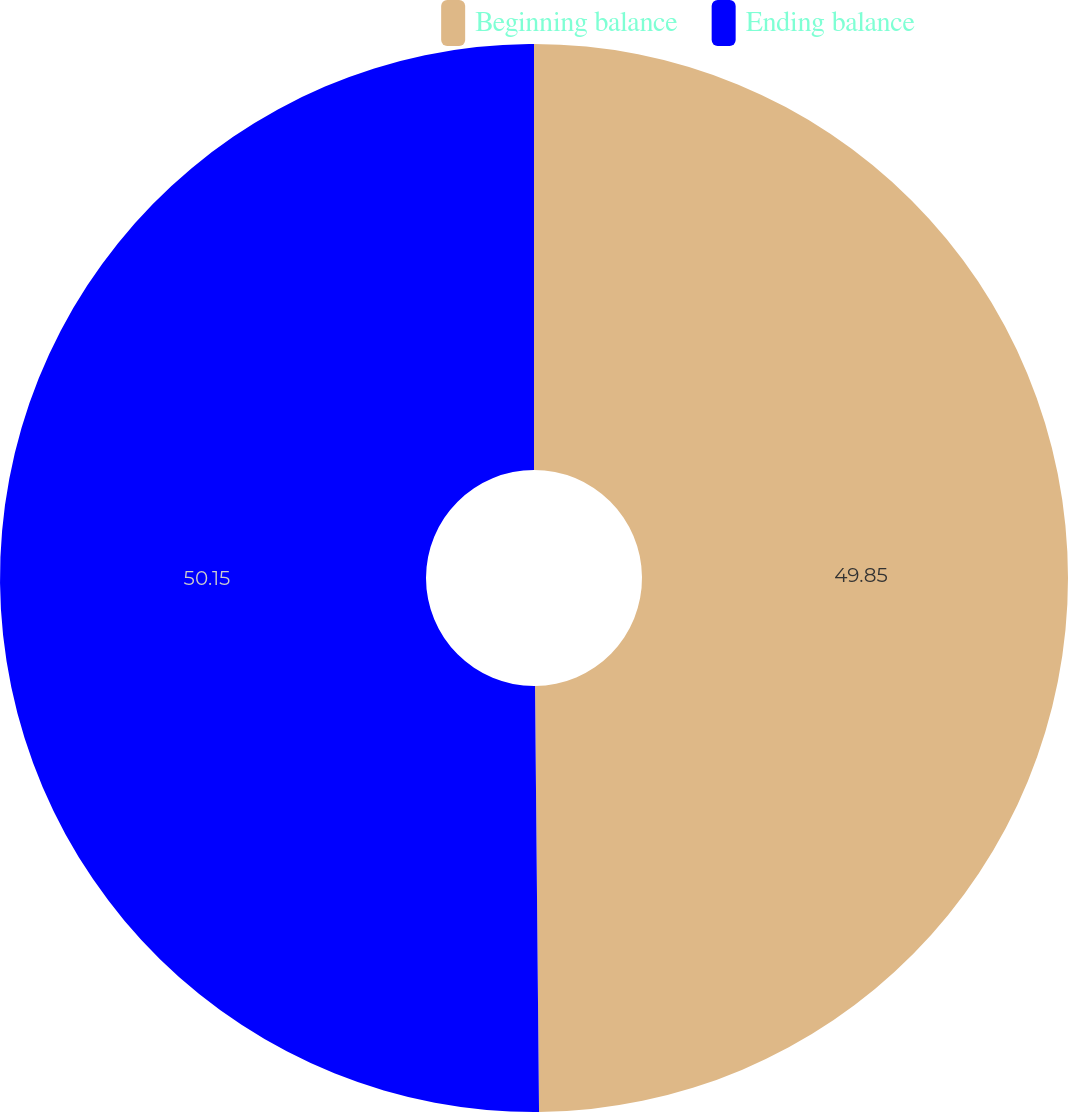Convert chart to OTSL. <chart><loc_0><loc_0><loc_500><loc_500><pie_chart><fcel>Beginning balance<fcel>Ending balance<nl><fcel>49.85%<fcel>50.15%<nl></chart> 